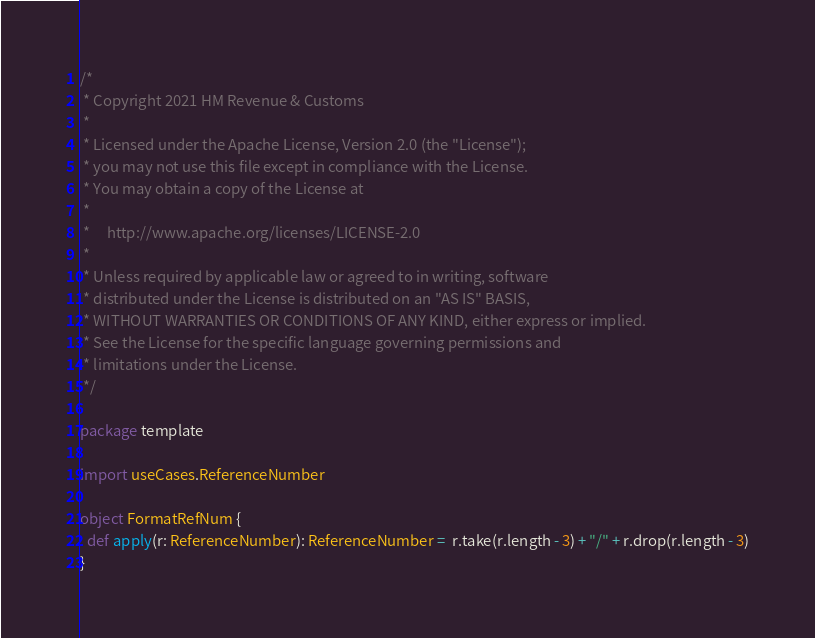Convert code to text. <code><loc_0><loc_0><loc_500><loc_500><_Scala_>/*
 * Copyright 2021 HM Revenue & Customs
 *
 * Licensed under the Apache License, Version 2.0 (the "License");
 * you may not use this file except in compliance with the License.
 * You may obtain a copy of the License at
 *
 *     http://www.apache.org/licenses/LICENSE-2.0
 *
 * Unless required by applicable law or agreed to in writing, software
 * distributed under the License is distributed on an "AS IS" BASIS,
 * WITHOUT WARRANTIES OR CONDITIONS OF ANY KIND, either express or implied.
 * See the License for the specific language governing permissions and
 * limitations under the License.
 */

package template

import useCases.ReferenceNumber

object FormatRefNum {
  def apply(r: ReferenceNumber): ReferenceNumber =  r.take(r.length - 3) + "/" + r.drop(r.length - 3)
}
</code> 